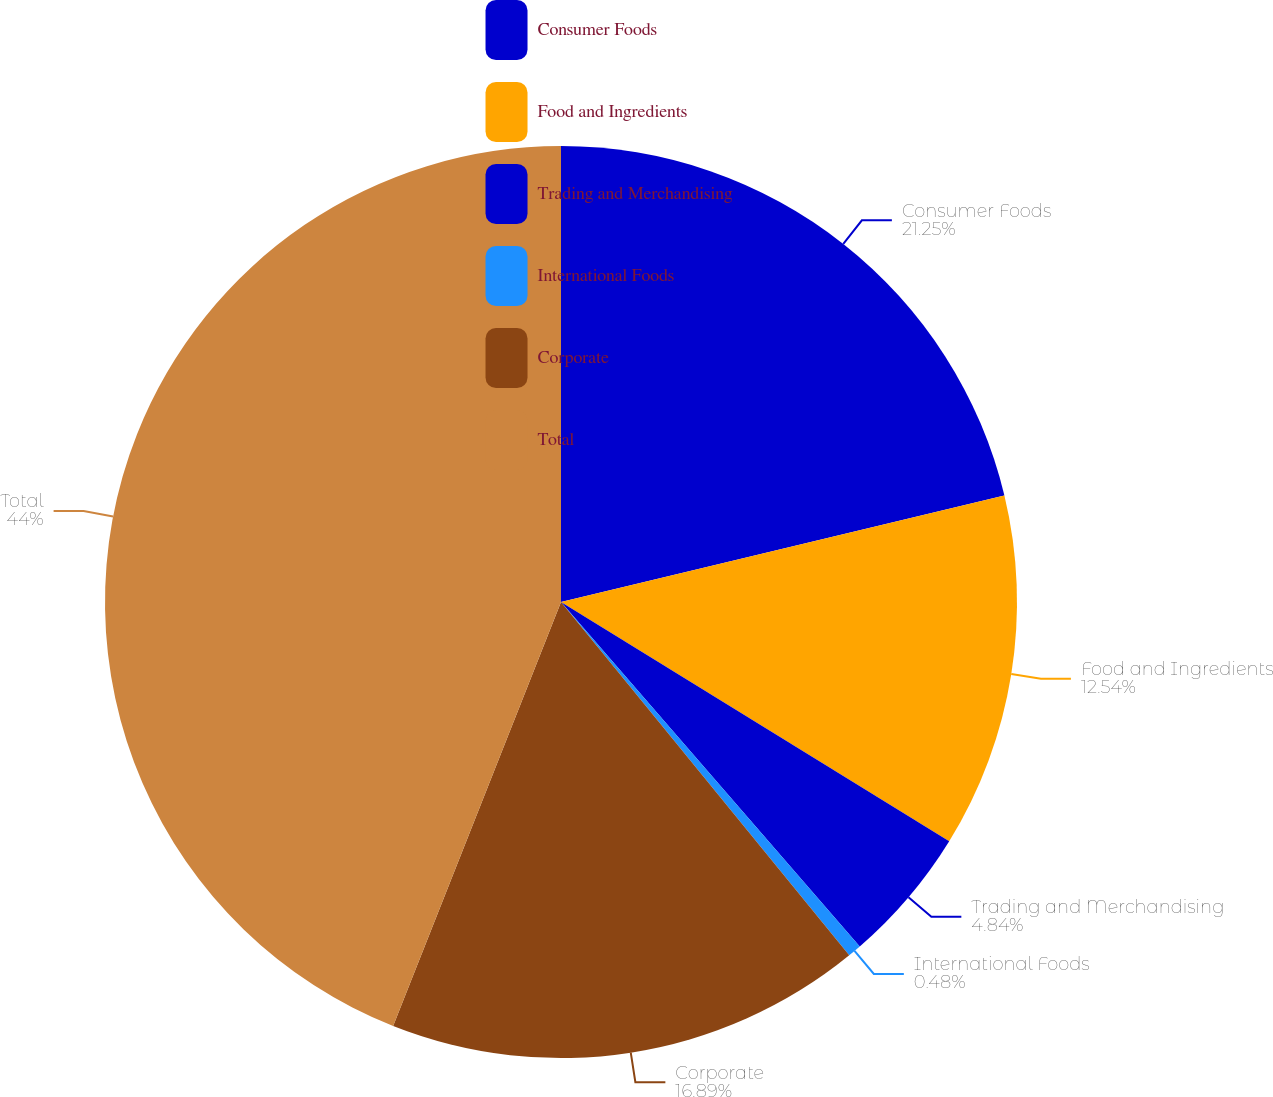Convert chart to OTSL. <chart><loc_0><loc_0><loc_500><loc_500><pie_chart><fcel>Consumer Foods<fcel>Food and Ingredients<fcel>Trading and Merchandising<fcel>International Foods<fcel>Corporate<fcel>Total<nl><fcel>21.25%<fcel>12.54%<fcel>4.84%<fcel>0.48%<fcel>16.89%<fcel>44.0%<nl></chart> 